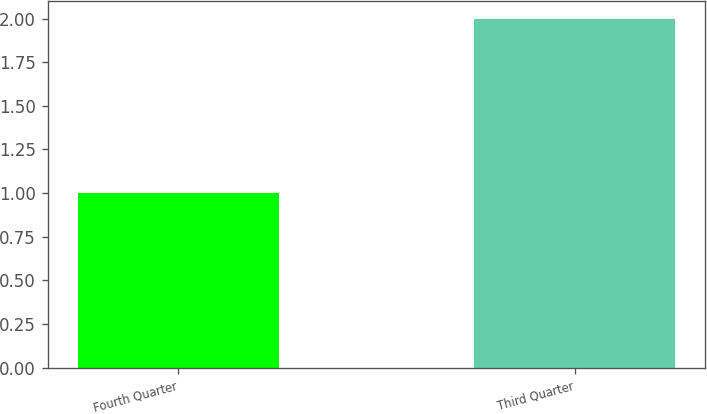Convert chart. <chart><loc_0><loc_0><loc_500><loc_500><bar_chart><fcel>Fourth Quarter<fcel>Third Quarter<nl><fcel>1<fcel>2<nl></chart> 